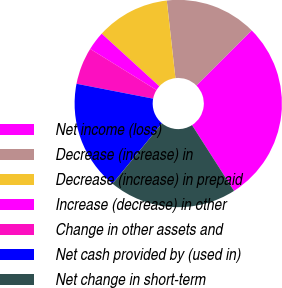Convert chart. <chart><loc_0><loc_0><loc_500><loc_500><pie_chart><fcel>Net income (loss)<fcel>Decrease (increase) in<fcel>Decrease (increase) in prepaid<fcel>Increase (decrease) in other<fcel>Change in other assets and<fcel>Net cash provided by (used in)<fcel>Net change in short-term<nl><fcel>28.43%<fcel>14.29%<fcel>11.46%<fcel>2.94%<fcel>5.78%<fcel>17.13%<fcel>19.97%<nl></chart> 